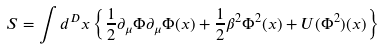Convert formula to latex. <formula><loc_0><loc_0><loc_500><loc_500>S = \int d ^ { D } x \left \{ \frac { 1 } { 2 } \partial _ { \mu } \Phi \partial _ { \mu } \Phi ( x ) + \frac { 1 } { 2 } \beta ^ { 2 } \Phi ^ { 2 } ( x ) + U ( \Phi ^ { 2 } ) ( x ) \right \}</formula> 